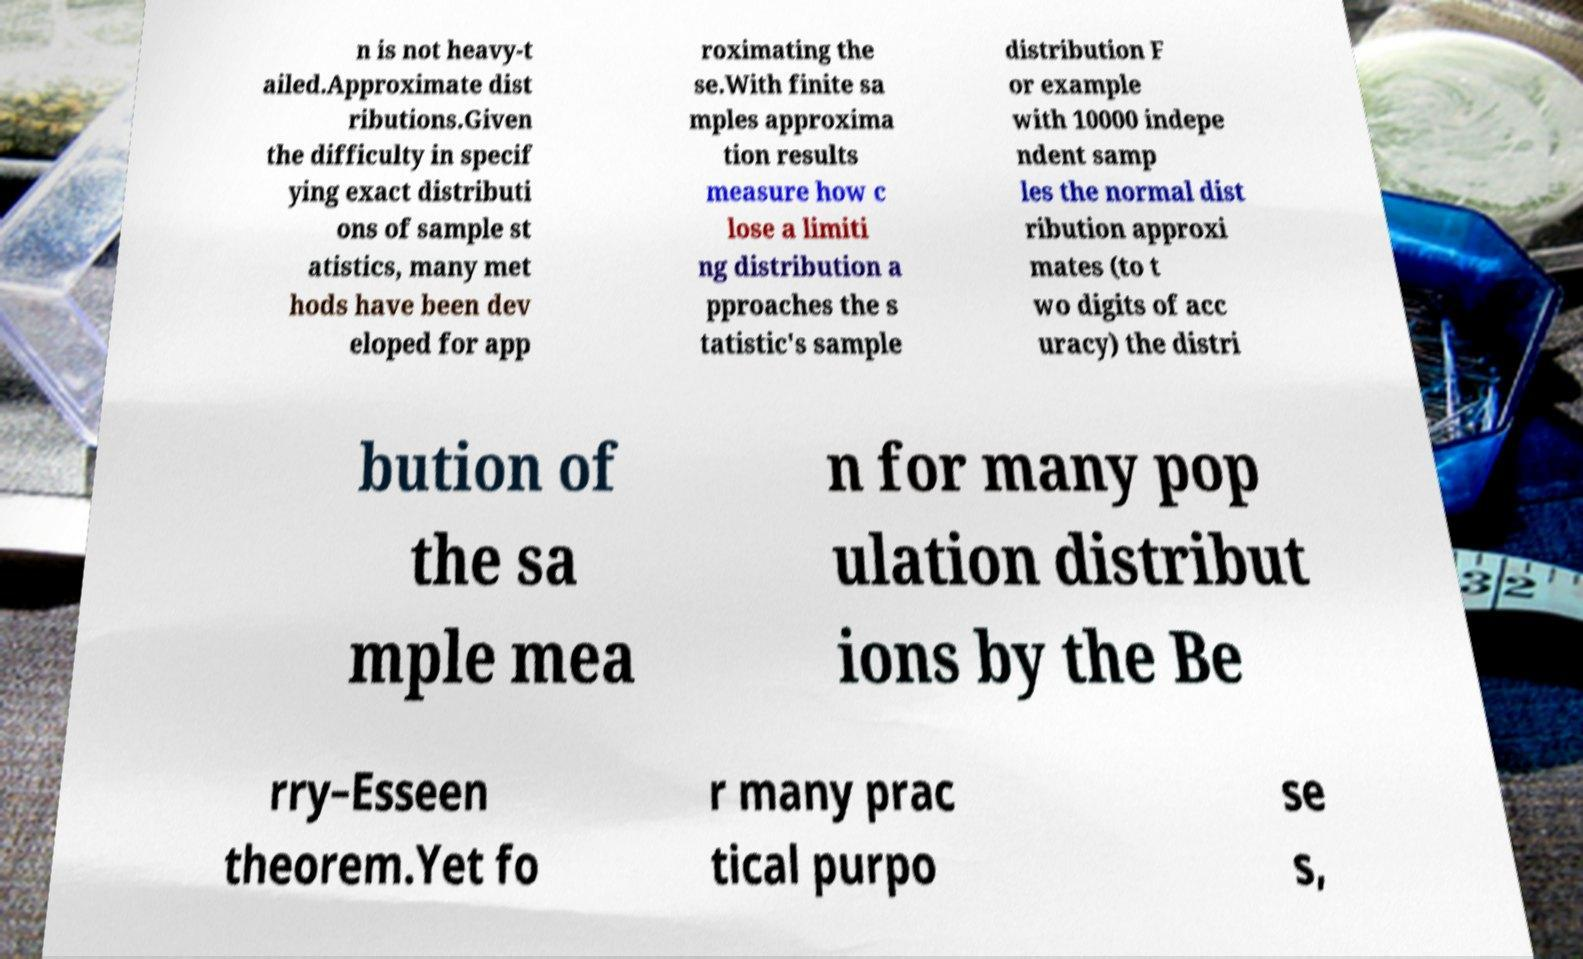For documentation purposes, I need the text within this image transcribed. Could you provide that? n is not heavy-t ailed.Approximate dist ributions.Given the difficulty in specif ying exact distributi ons of sample st atistics, many met hods have been dev eloped for app roximating the se.With finite sa mples approxima tion results measure how c lose a limiti ng distribution a pproaches the s tatistic's sample distribution F or example with 10000 indepe ndent samp les the normal dist ribution approxi mates (to t wo digits of acc uracy) the distri bution of the sa mple mea n for many pop ulation distribut ions by the Be rry–Esseen theorem.Yet fo r many prac tical purpo se s, 